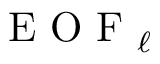<formula> <loc_0><loc_0><loc_500><loc_500>E O F _ { \ell }</formula> 